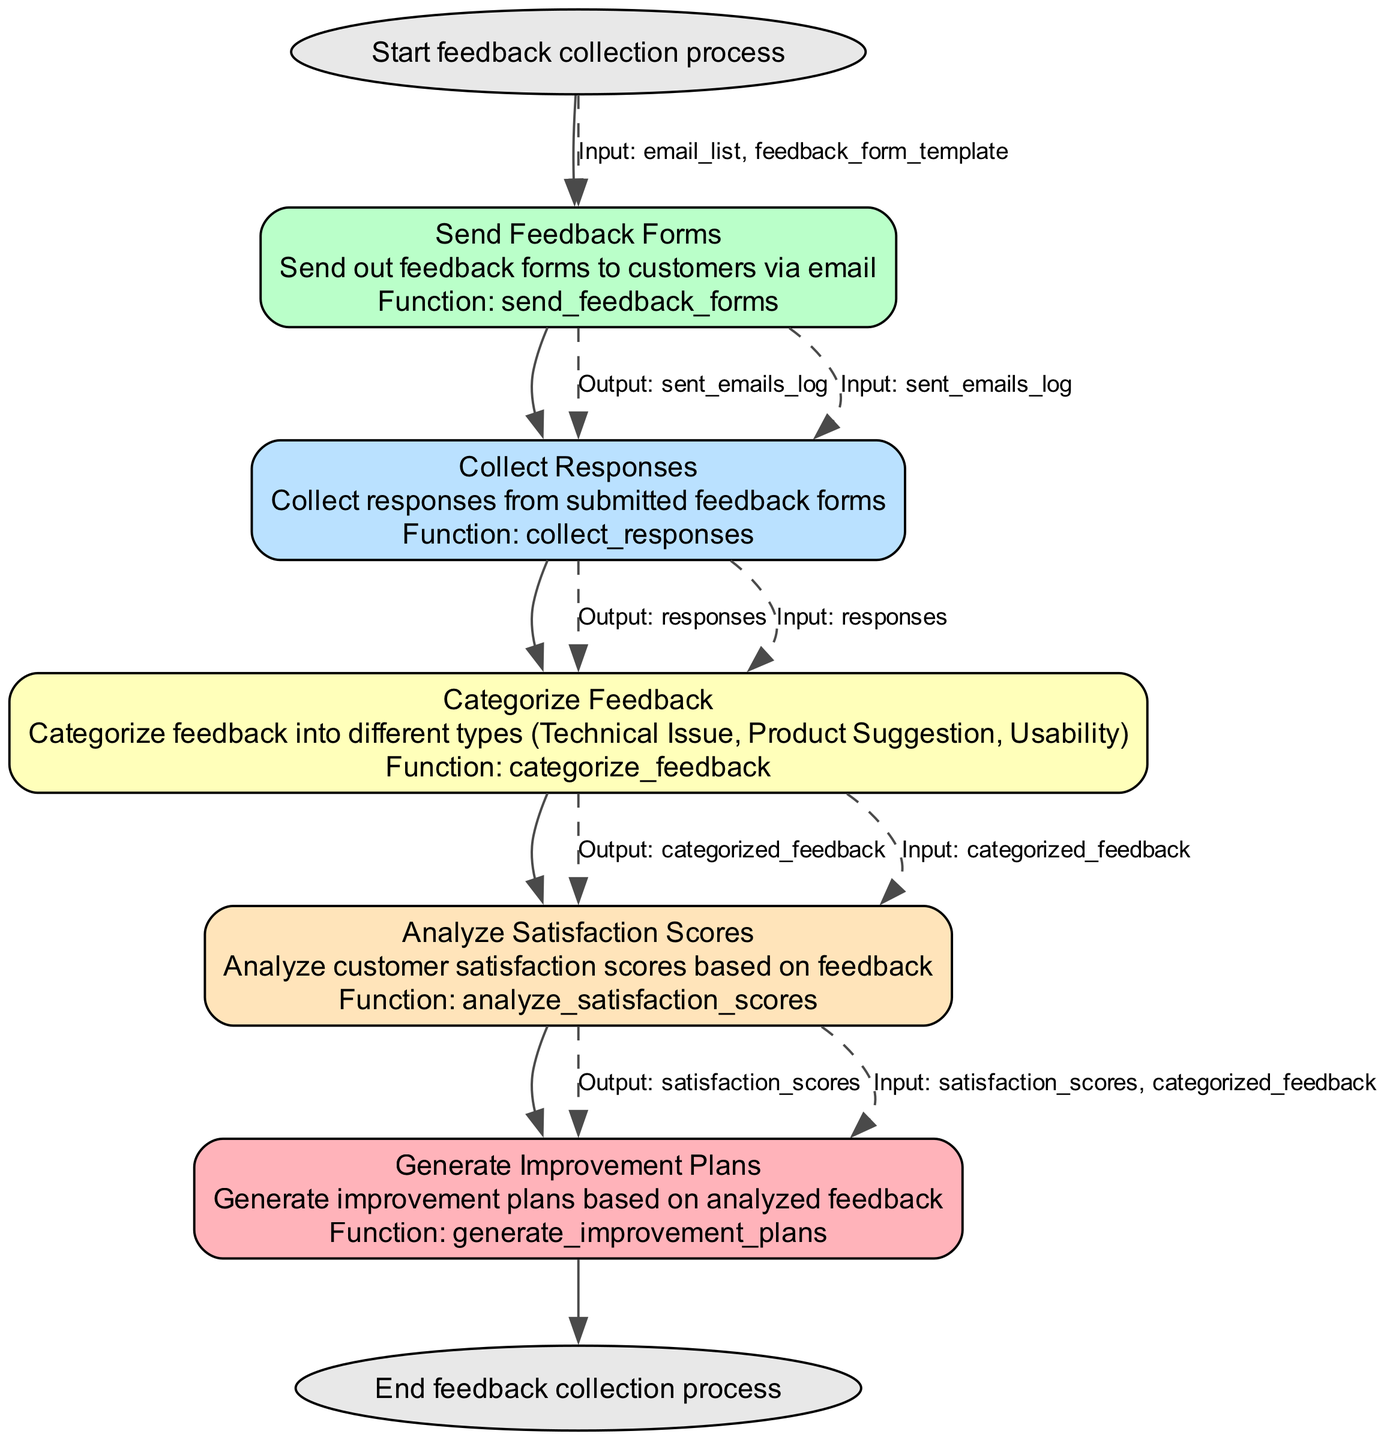What is the starting point of the flowchart? The starting point of the flowchart is labeled "Start," indicating the initiation of the feedback collection process. This is typically where any flowchart begins to illustrate the first action taken.
Answer: Start feedback collection process How many functions are listed in the flowchart? The flowchart contains five distinct functions: send_feedback_forms, collect_responses, categorize_feedback, analyze_satisfaction_scores, and generate_improvement_plans. Each function corresponds to a step in the feedback collection and analysis process.
Answer: 5 What is the output of the "Categorize Feedback" step? The output of the "Categorize Feedback" step is labeled "categorized_feedback." This output represents the data after it has been categorized into different types based on the customer responses.
Answer: categorized_feedback Which step receives the output from "Collect Responses"? The "Categorize Feedback" step receives the output from "Collect Responses." This indicates that the categorized feedback is processed using the responses collected from customers, linking these two steps in the flowchart.
Answer: Categorize Feedback What color is used for the "Send Feedback Forms" node? The "Send Feedback Forms" node is colored using the palette defined for function nodes, specifically a color from the set of defined colors (#FFB3BA, #BAFFC9, #BAE1FF, #FFFFBA, #FFE4BA). The specific color assigned to this function is determined by its position in the list of elements.
Answer: #FFB3BA Which node would be the last to execute in this flowchart? The last node to execute in this flowchart is the "End" node. This node indicates the conclusion of the feedback collection process, marking the final step in the sequence of actions outlined in the flowchart.
Answer: End feedback collection process How many inputs are required by the "Generate Improvement Plans" function? The "Generate Improvement Plans" function requires two inputs: "satisfaction_scores" and "categorized_feedback." This indicates that it needs feedback analysis results and categorization to formulate improvement plans.
Answer: 2 Which two outputs are generated directly from the "Analyze Satisfaction Scores"? The two outputs generated directly from the "Analyze Satisfaction Scores" function are "satisfaction_scores" and "categorized_feedback." This means that after analyzing, both types of data are passed on for further processing, although only the satisfaction scores are singularly noted.
Answer: satisfaction_scores, categorized_feedback What type of feedback is categorized in the "Categorize Feedback" step? The feedback categorized in the "Categorize Feedback" step can include types such as Technical Issue, Product Suggestion, and Usability. This step aims to sort feedback into these specific categories for better analysis and action planning.
Answer: Technical Issue, Product Suggestion, Usability 